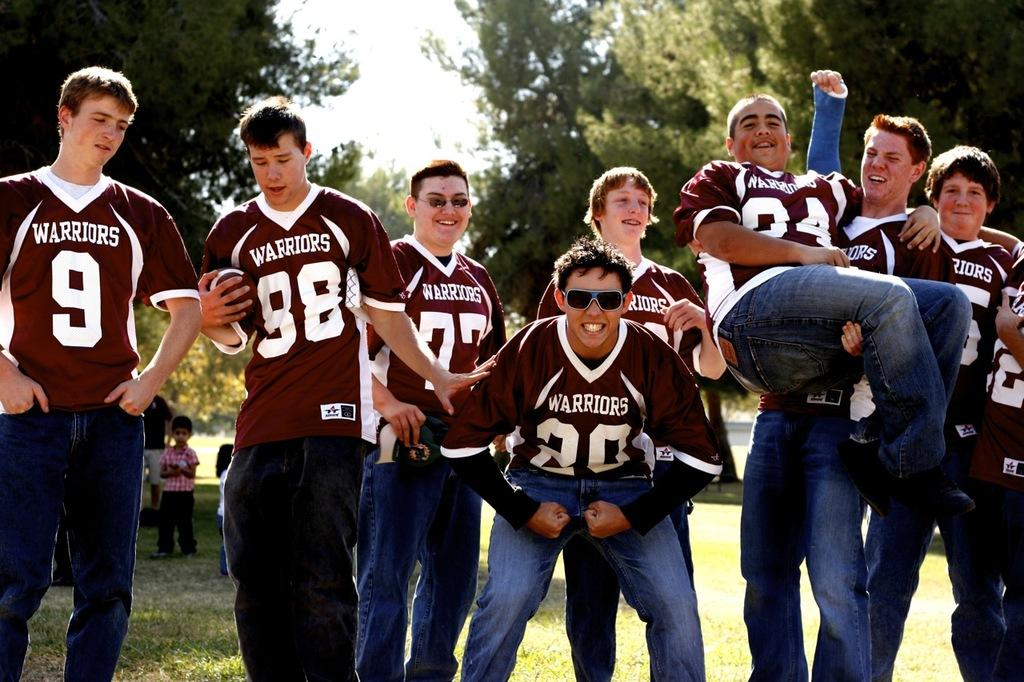<image>
Render a clear and concise summary of the photo. Group of guys posing for a photo including one wearing a number 9. 